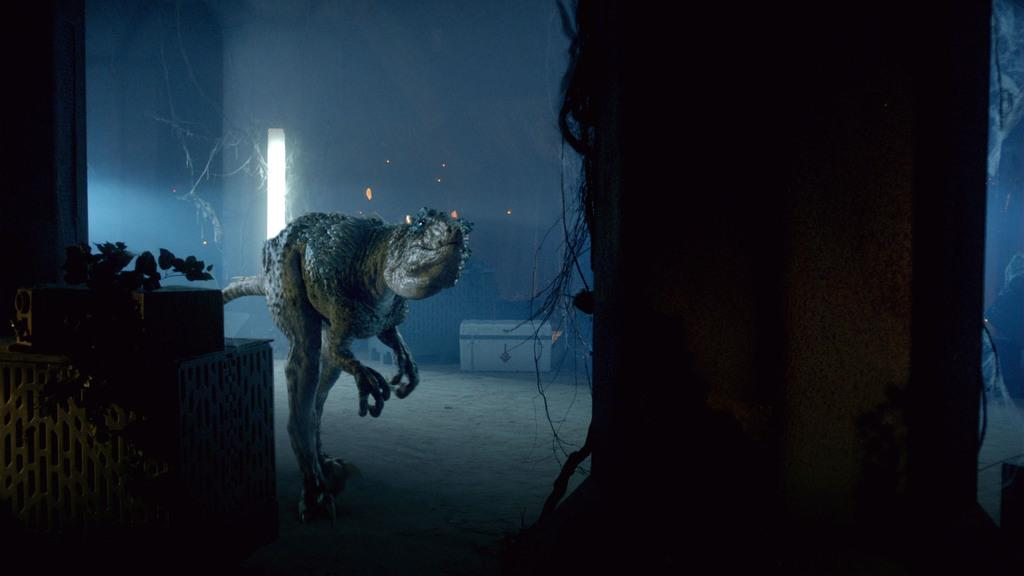What is the main subject of the image? There is a dinosaur in the image. What object is located in the middle of the image? There is a trunk box in the middle of the image. What type of vegetation can be seen in the image? There are leaves in the image. Where are the boxes located in the image? There are boxes on the left side of the image. How many rays are visible in the image? There are no rays visible in the image. Can you describe the ladybug's pattern in the image? There is no ladybug present in the image. 